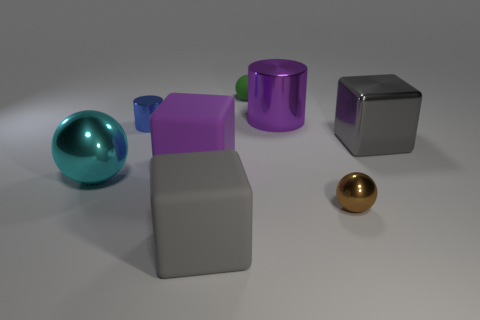Add 1 blocks. How many objects exist? 9 Subtract all cylinders. How many objects are left? 6 Add 4 small cyan spheres. How many small cyan spheres exist? 4 Subtract 0 brown cylinders. How many objects are left? 8 Subtract all tiny blue metal objects. Subtract all large purple cylinders. How many objects are left? 6 Add 1 shiny cylinders. How many shiny cylinders are left? 3 